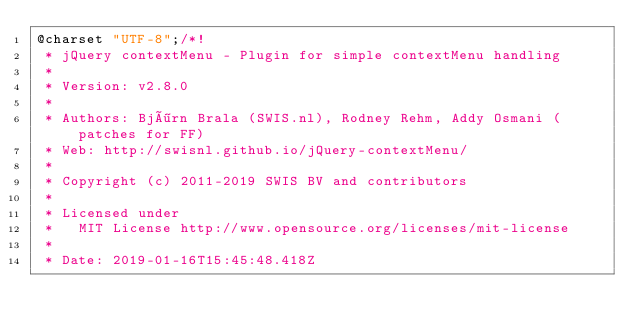<code> <loc_0><loc_0><loc_500><loc_500><_CSS_>@charset "UTF-8";/*!
 * jQuery contextMenu - Plugin for simple contextMenu handling
 *
 * Version: v2.8.0
 *
 * Authors: Björn Brala (SWIS.nl), Rodney Rehm, Addy Osmani (patches for FF)
 * Web: http://swisnl.github.io/jQuery-contextMenu/
 *
 * Copyright (c) 2011-2019 SWIS BV and contributors
 *
 * Licensed under
 *   MIT License http://www.opensource.org/licenses/mit-license
 *
 * Date: 2019-01-16T15:45:48.418Z</code> 